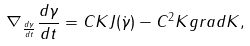<formula> <loc_0><loc_0><loc_500><loc_500>\nabla _ { \frac { d \gamma } { d t } } \frac { d \gamma } { d t } = C K J ( \dot { \gamma } ) - C ^ { 2 } K g r a d K ,</formula> 